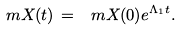<formula> <loc_0><loc_0><loc_500><loc_500>\ m X ( t ) \, = \, \ m X ( 0 ) e ^ { \Lambda _ { 1 } t } .</formula> 